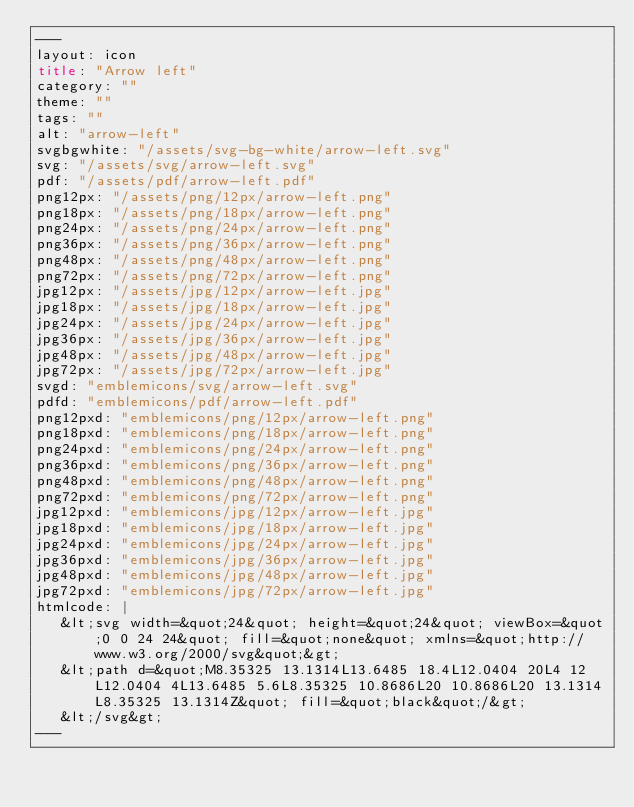Convert code to text. <code><loc_0><loc_0><loc_500><loc_500><_HTML_>---
layout: icon
title: "Arrow left"
category: ""
theme: ""
tags: ""
alt: "arrow-left"
svgbgwhite: "/assets/svg-bg-white/arrow-left.svg"
svg: "/assets/svg/arrow-left.svg"
pdf: "/assets/pdf/arrow-left.pdf"
png12px: "/assets/png/12px/arrow-left.png"
png18px: "/assets/png/18px/arrow-left.png"
png24px: "/assets/png/24px/arrow-left.png"
png36px: "/assets/png/36px/arrow-left.png"
png48px: "/assets/png/48px/arrow-left.png"
png72px: "/assets/png/72px/arrow-left.png"
jpg12px: "/assets/jpg/12px/arrow-left.jpg"
jpg18px: "/assets/jpg/18px/arrow-left.jpg"
jpg24px: "/assets/jpg/24px/arrow-left.jpg"
jpg36px: "/assets/jpg/36px/arrow-left.jpg"
jpg48px: "/assets/jpg/48px/arrow-left.jpg"
jpg72px: "/assets/jpg/72px/arrow-left.jpg"
svgd: "emblemicons/svg/arrow-left.svg"
pdfd: "emblemicons/pdf/arrow-left.pdf"
png12pxd: "emblemicons/png/12px/arrow-left.png"
png18pxd: "emblemicons/png/18px/arrow-left.png"
png24pxd: "emblemicons/png/24px/arrow-left.png"
png36pxd: "emblemicons/png/36px/arrow-left.png"
png48pxd: "emblemicons/png/48px/arrow-left.png"
png72pxd: "emblemicons/png/72px/arrow-left.png"
jpg12pxd: "emblemicons/jpg/12px/arrow-left.jpg"
jpg18pxd: "emblemicons/jpg/18px/arrow-left.jpg"
jpg24pxd: "emblemicons/jpg/24px/arrow-left.jpg"
jpg36pxd: "emblemicons/jpg/36px/arrow-left.jpg"
jpg48pxd: "emblemicons/jpg/48px/arrow-left.jpg"
jpg72pxd: "emblemicons/jpg/72px/arrow-left.jpg"
htmlcode: |
   &lt;svg width=&quot;24&quot; height=&quot;24&quot; viewBox=&quot;0 0 24 24&quot; fill=&quot;none&quot; xmlns=&quot;http://www.w3.org/2000/svg&quot;&gt;
   &lt;path d=&quot;M8.35325 13.1314L13.6485 18.4L12.0404 20L4 12L12.0404 4L13.6485 5.6L8.35325 10.8686L20 10.8686L20 13.1314L8.35325 13.1314Z&quot; fill=&quot;black&quot;/&gt;
   &lt;/svg&gt;
---</code> 